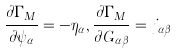Convert formula to latex. <formula><loc_0><loc_0><loc_500><loc_500>\frac { \partial \Gamma _ { M } } { \partial \psi _ { \alpha } } = - \eta _ { \alpha } , \frac { \partial \Gamma _ { M } } { \partial G _ { \alpha \beta } } = j _ { \alpha \beta }</formula> 